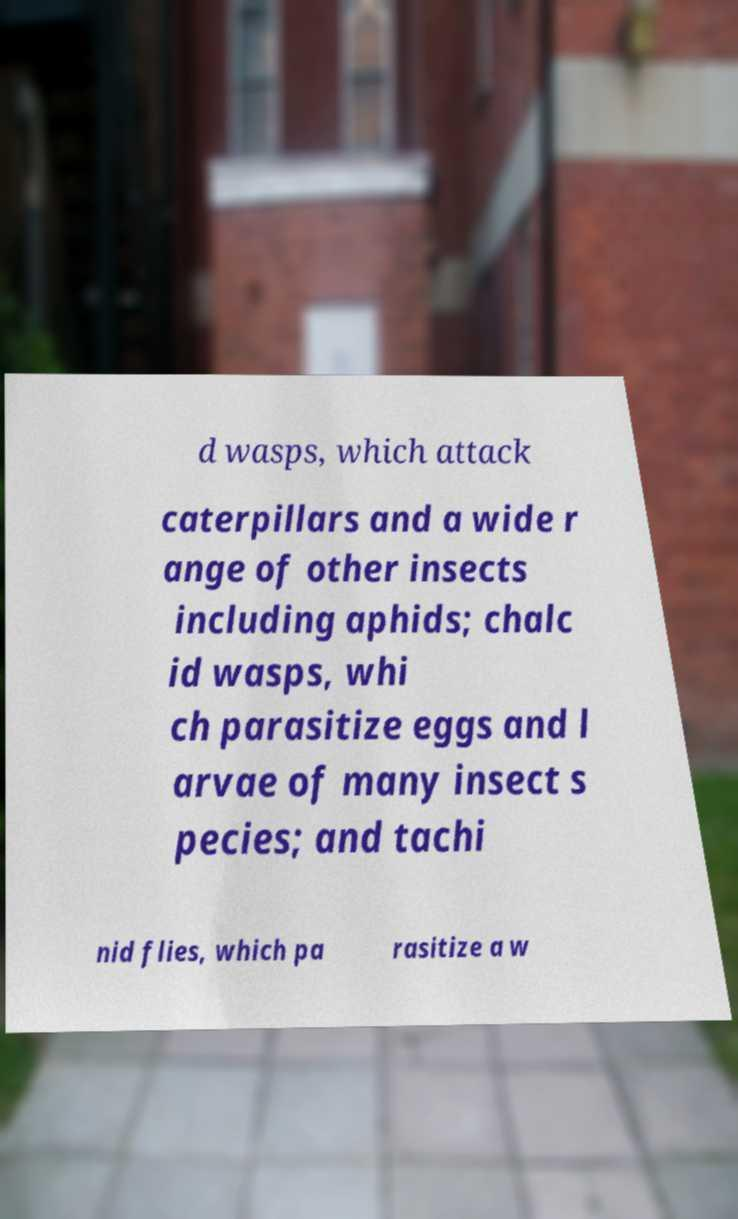I need the written content from this picture converted into text. Can you do that? d wasps, which attack caterpillars and a wide r ange of other insects including aphids; chalc id wasps, whi ch parasitize eggs and l arvae of many insect s pecies; and tachi nid flies, which pa rasitize a w 